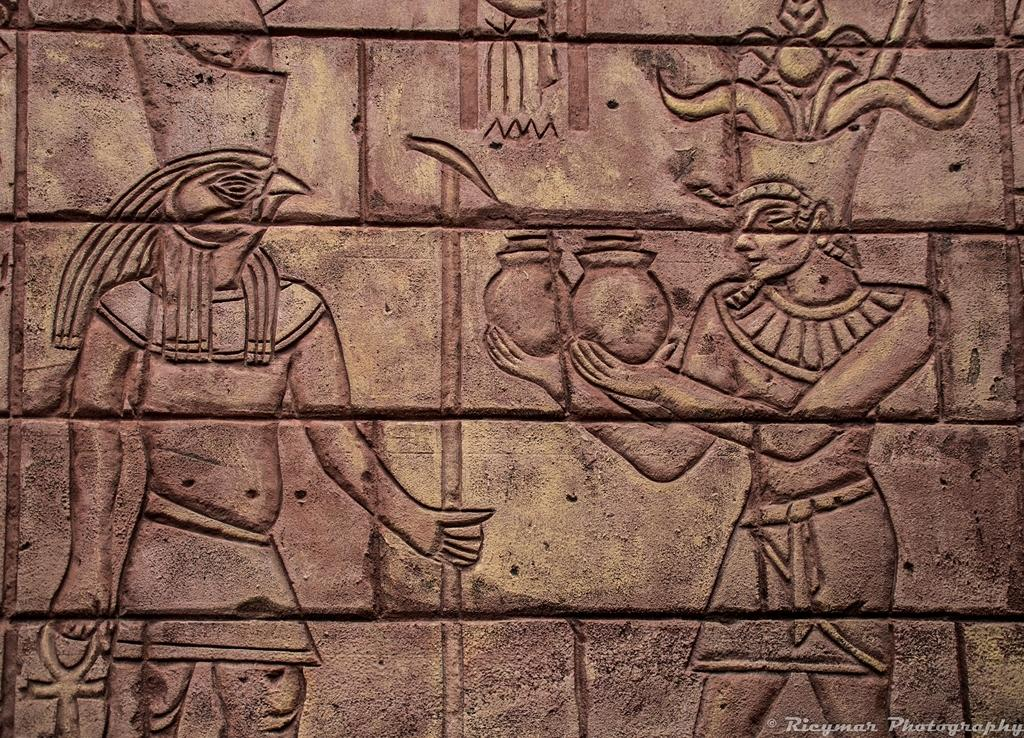What is the main feature of the image? The main feature of the image is a wall. What can be seen on the wall? The wall has ancient sculptures on it. Where is the sister of the person who took the picture in the image? There is no information about a sister in the image, so we cannot determine her location. Can you see a yak in the image? There is no yak present in the image. 